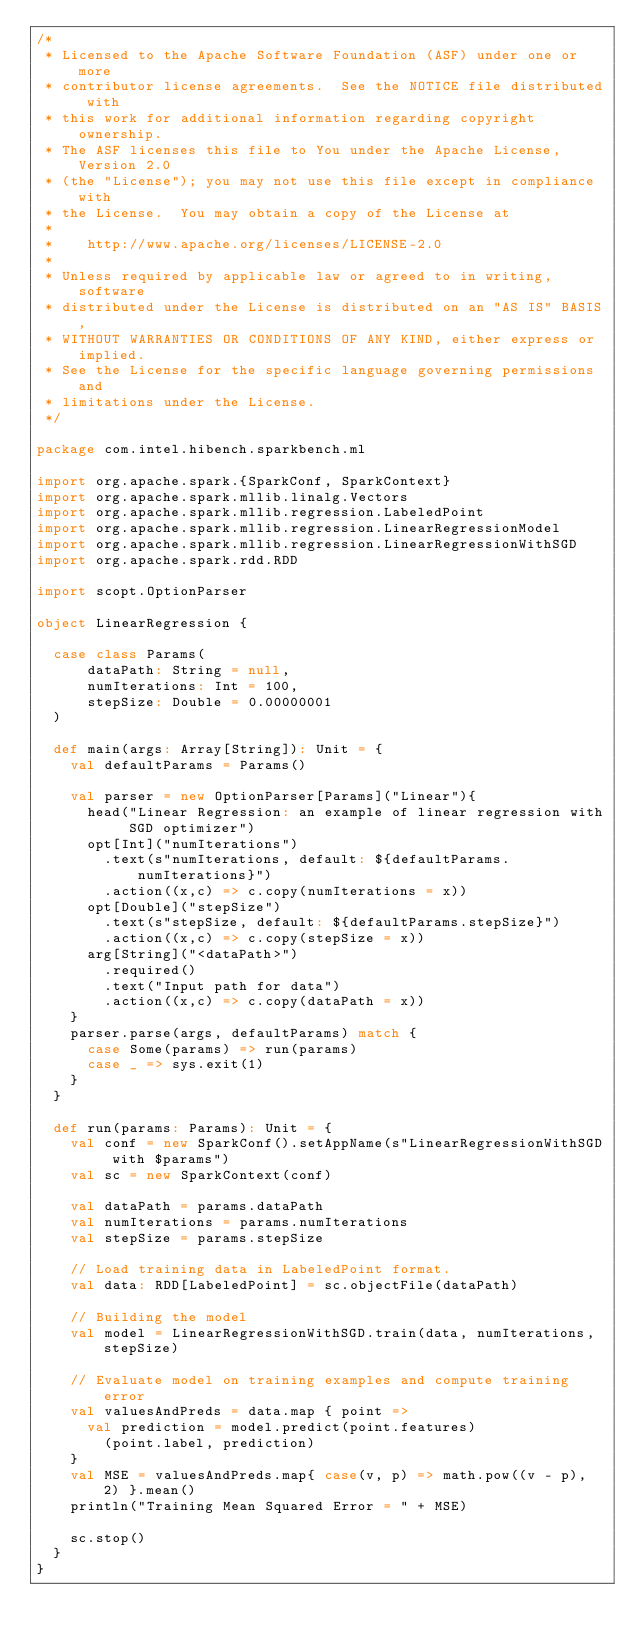<code> <loc_0><loc_0><loc_500><loc_500><_Scala_>/*
 * Licensed to the Apache Software Foundation (ASF) under one or more
 * contributor license agreements.  See the NOTICE file distributed with
 * this work for additional information regarding copyright ownership.
 * The ASF licenses this file to You under the Apache License, Version 2.0
 * (the "License"); you may not use this file except in compliance with
 * the License.  You may obtain a copy of the License at
 *
 *    http://www.apache.org/licenses/LICENSE-2.0
 *
 * Unless required by applicable law or agreed to in writing, software
 * distributed under the License is distributed on an "AS IS" BASIS,
 * WITHOUT WARRANTIES OR CONDITIONS OF ANY KIND, either express or implied.
 * See the License for the specific language governing permissions and
 * limitations under the License.
 */

package com.intel.hibench.sparkbench.ml

import org.apache.spark.{SparkConf, SparkContext}
import org.apache.spark.mllib.linalg.Vectors
import org.apache.spark.mllib.regression.LabeledPoint
import org.apache.spark.mllib.regression.LinearRegressionModel
import org.apache.spark.mllib.regression.LinearRegressionWithSGD
import org.apache.spark.rdd.RDD

import scopt.OptionParser

object LinearRegression {

  case class Params(
      dataPath: String = null,
      numIterations: Int = 100,
      stepSize: Double = 0.00000001
  )

  def main(args: Array[String]): Unit = {
    val defaultParams = Params()

    val parser = new OptionParser[Params]("Linear"){
      head("Linear Regression: an example of linear regression with SGD optimizer")
      opt[Int]("numIterations")
        .text(s"numIterations, default: ${defaultParams.numIterations}")
        .action((x,c) => c.copy(numIterations = x))
      opt[Double]("stepSize")
        .text(s"stepSize, default: ${defaultParams.stepSize}")
        .action((x,c) => c.copy(stepSize = x))
      arg[String]("<dataPath>")
        .required()
        .text("Input path for data")
        .action((x,c) => c.copy(dataPath = x))
    }
    parser.parse(args, defaultParams) match {
      case Some(params) => run(params)
      case _ => sys.exit(1)
    }
  }
   
  def run(params: Params): Unit = {
    val conf = new SparkConf().setAppName(s"LinearRegressionWithSGD with $params")
    val sc = new SparkContext(conf)
    
    val dataPath = params.dataPath
    val numIterations = params.numIterations
    val stepSize = params.stepSize

    // Load training data in LabeledPoint format.
    val data: RDD[LabeledPoint] = sc.objectFile(dataPath)
    
    // Building the model
    val model = LinearRegressionWithSGD.train(data, numIterations, stepSize)

    // Evaluate model on training examples and compute training error
    val valuesAndPreds = data.map { point =>
      val prediction = model.predict(point.features)
        (point.label, prediction)
    }
    val MSE = valuesAndPreds.map{ case(v, p) => math.pow((v - p), 2) }.mean()
    println("Training Mean Squared Error = " + MSE)

    sc.stop()
  }
}
</code> 